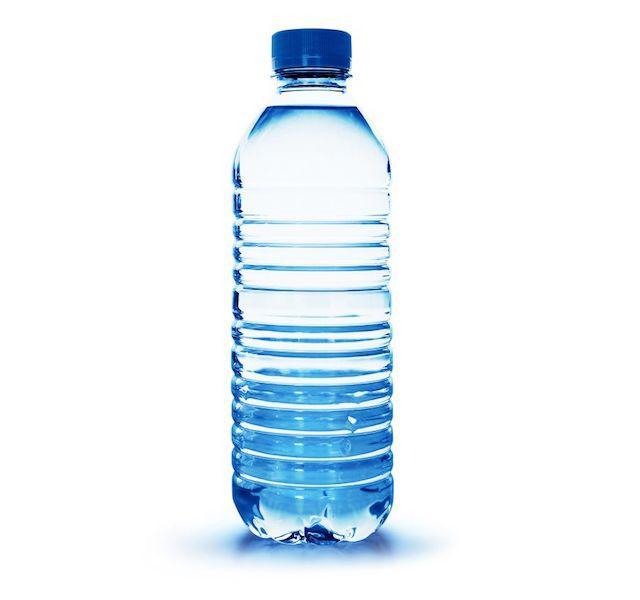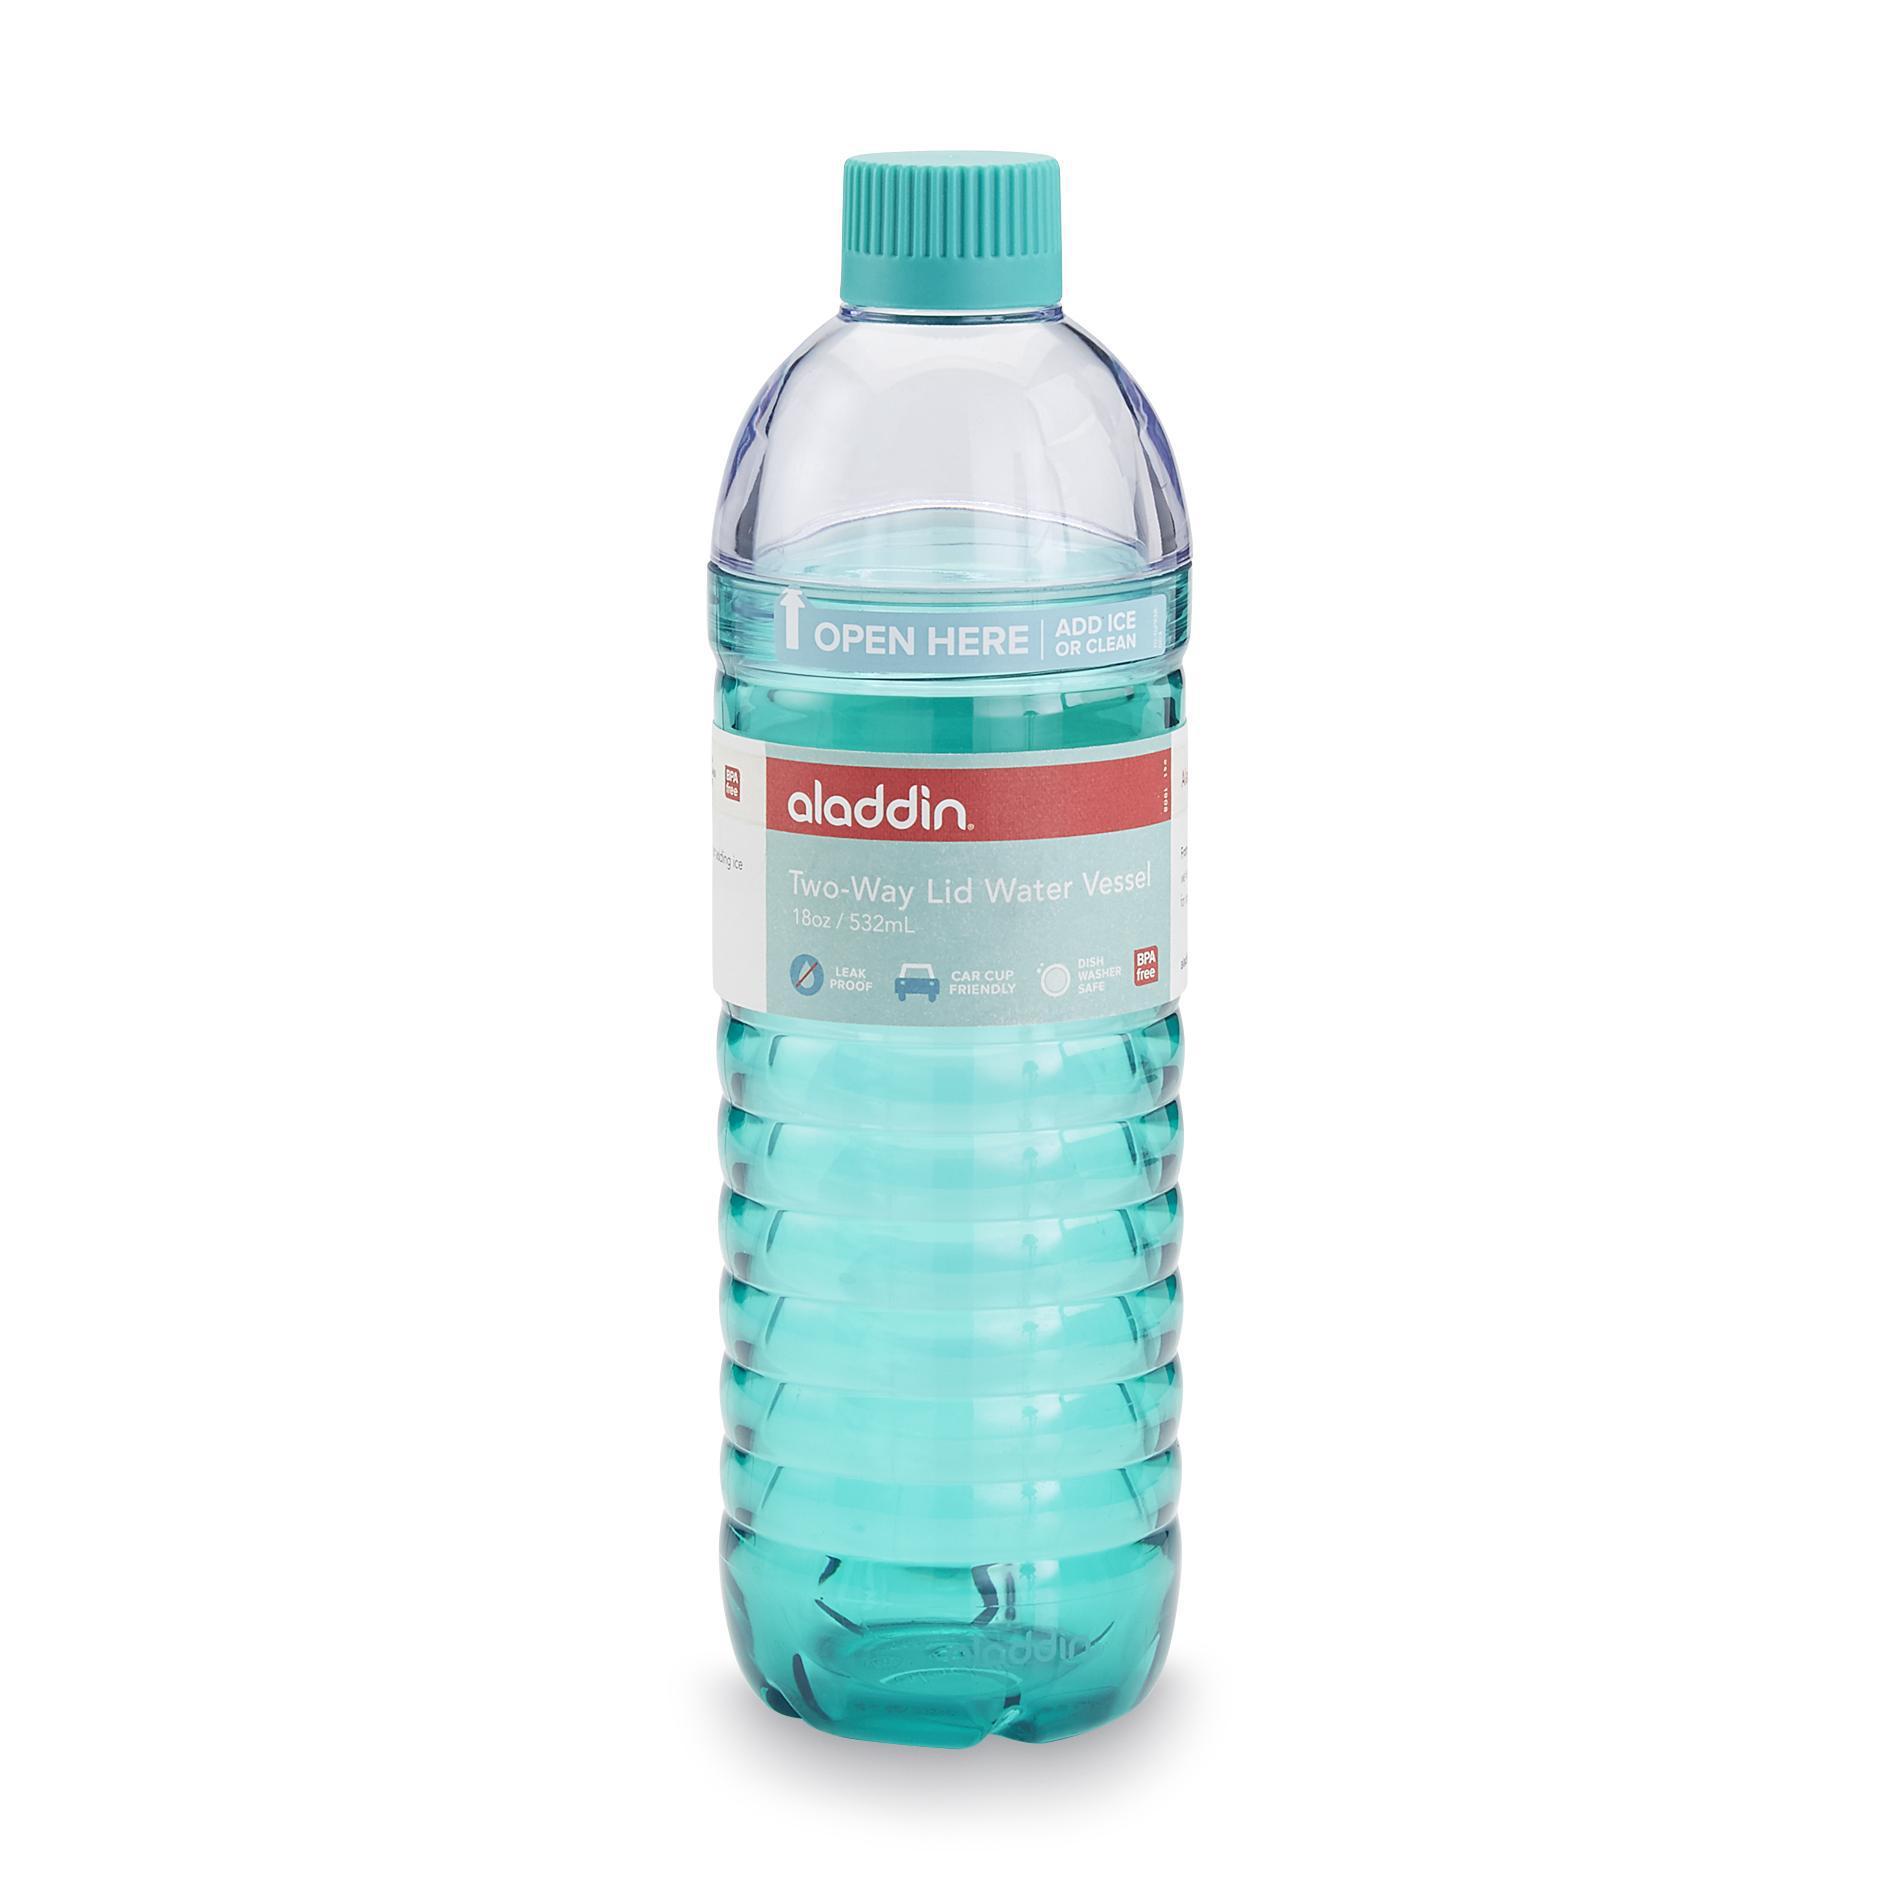The first image is the image on the left, the second image is the image on the right. Evaluate the accuracy of this statement regarding the images: "One image shows at least one teal colored stainless steel water bottle with a silver chrome cap". Is it true? Answer yes or no. No. The first image is the image on the left, the second image is the image on the right. Examine the images to the left and right. Is the description "An image shows at least one opaque robin's-egg blue water bottle with a silver cap on it." accurate? Answer yes or no. No. 